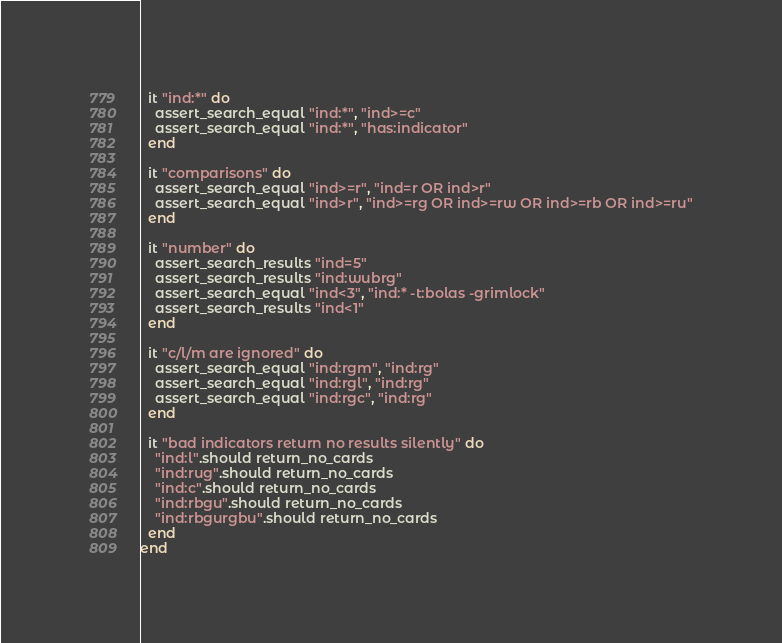Convert code to text. <code><loc_0><loc_0><loc_500><loc_500><_Ruby_>
  it "ind:*" do
    assert_search_equal "ind:*", "ind>=c"
    assert_search_equal "ind:*", "has:indicator"
  end

  it "comparisons" do
    assert_search_equal "ind>=r", "ind=r OR ind>r"
    assert_search_equal "ind>r", "ind>=rg OR ind>=rw OR ind>=rb OR ind>=ru"
  end

  it "number" do
    assert_search_results "ind=5"
    assert_search_results "ind:wubrg"
    assert_search_equal "ind<3", "ind:* -t:bolas -grimlock"
    assert_search_results "ind<1"
  end

  it "c/l/m are ignored" do
    assert_search_equal "ind:rgm", "ind:rg"
    assert_search_equal "ind:rgl", "ind:rg"
    assert_search_equal "ind:rgc", "ind:rg"
  end

  it "bad indicators return no results silently" do
    "ind:l".should return_no_cards
    "ind:rug".should return_no_cards
    "ind:c".should return_no_cards
    "ind:rbgu".should return_no_cards
    "ind:rbgurgbu".should return_no_cards
  end
end
</code> 